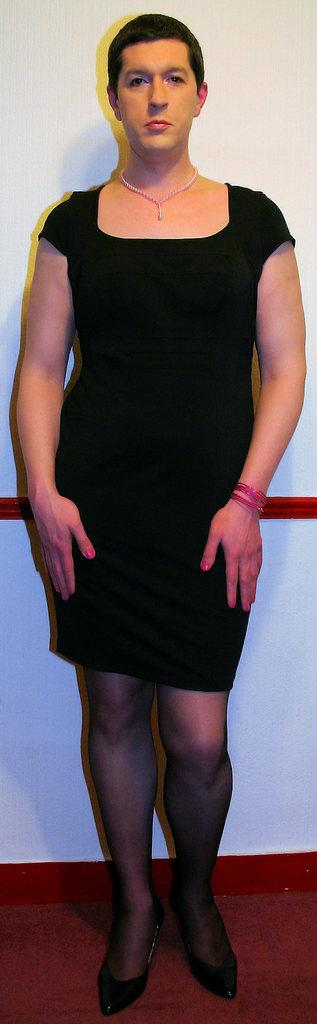What is the main subject of the image? There is a person standing in the image. What is the person wearing in the image? The person is wearing a necklace and a black color dress. What can be seen in the background of the image? There is a white color wall in the background of the image. How many babies are being held by the person in the image? There are no babies present in the image; the person is standing alone. What type of tooth can be seen in the person's mouth in the image? There is no tooth visible in the person's mouth in the image. 